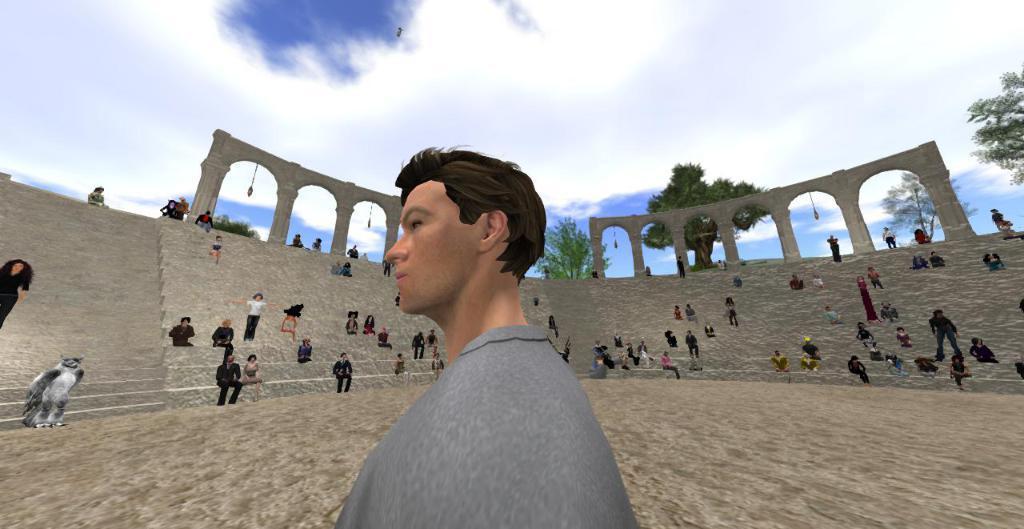Describe this image in one or two sentences. This picture is animated. Here we can see a man who is standing on the ground. On the background we can see a group of persons who are near to the stairs. On the left there is a cat which is near to this girl. On the top we can see sky and clouds. Here we can see trees. 